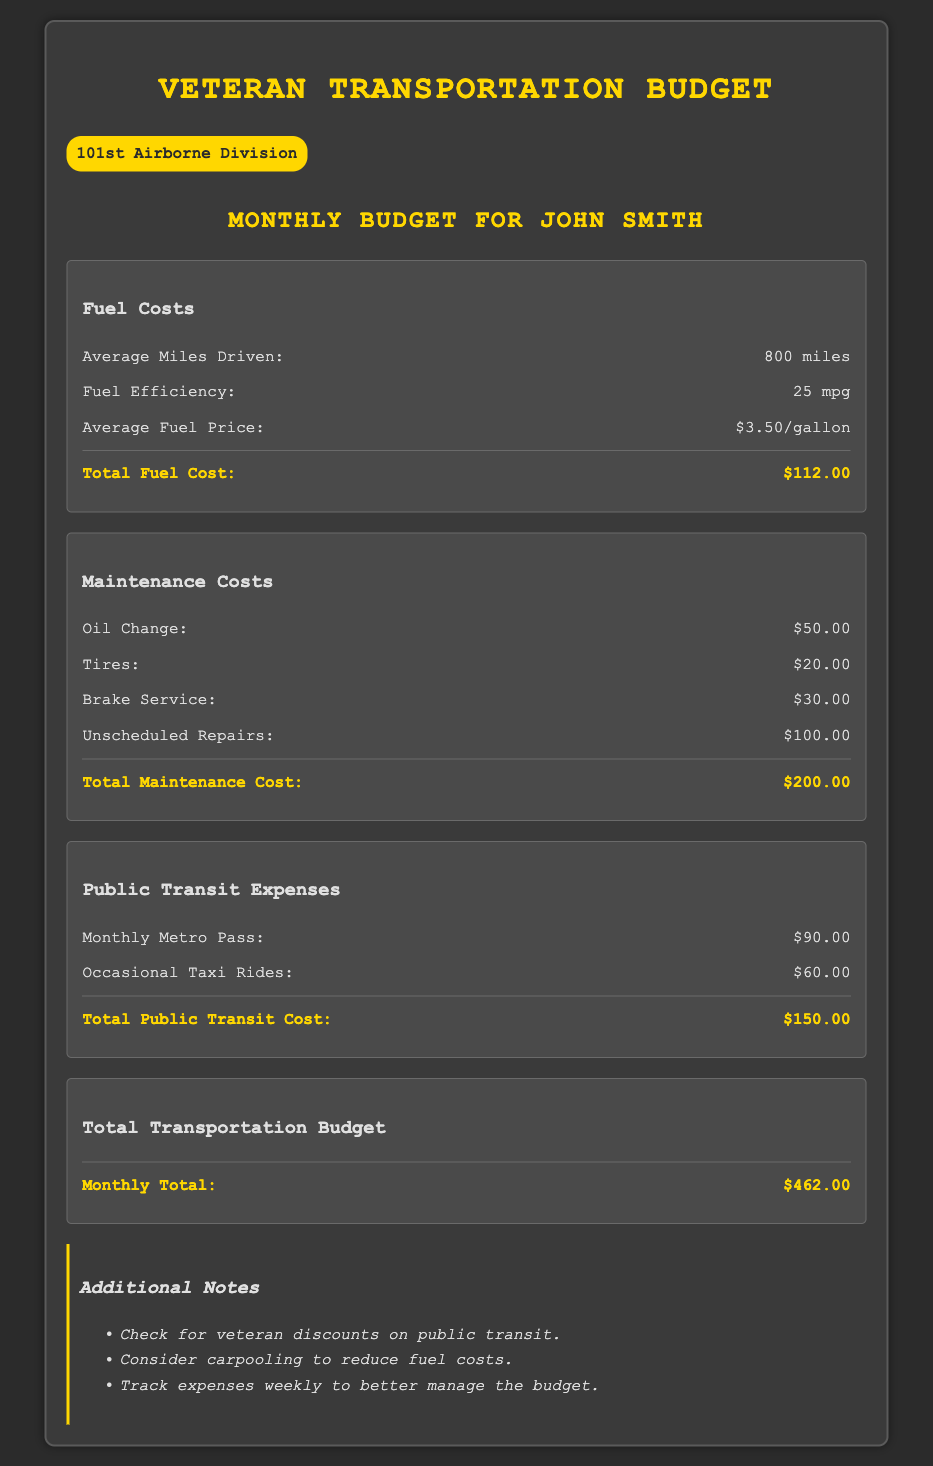what is the average miles driven? The average miles driven is specified in the fuel costs section as 800 miles.
Answer: 800 miles what is the average fuel price? The average fuel price is listed under fuel costs as $3.50/gallon.
Answer: $3.50/gallon what are the total maintenance costs? The total maintenance costs are the sum of individual maintenance expenses, which equals $200.00.
Answer: $200.00 how much does a monthly metro pass cost? The cost of a monthly metro pass is found under public transit expenses and is $90.00.
Answer: $90.00 what is the total transportation budget? The total transportation budget is at the end of the document and amounts to $462.00.
Answer: $462.00 what is the cost of unscheduled repairs? The cost of unscheduled repairs is listed under maintenance costs as $100.00.
Answer: $100.00 what should be tracked weekly? The document suggests tracking expenses weekly to better manage the budget.
Answer: expenses how much are occasional taxi rides? Occasional taxi rides are mentioned under public transit expenses as costing $60.00.
Answer: $60.00 what veteran discounts should be checked? The notes mention checking for veteran discounts on public transit.
Answer: public transit 